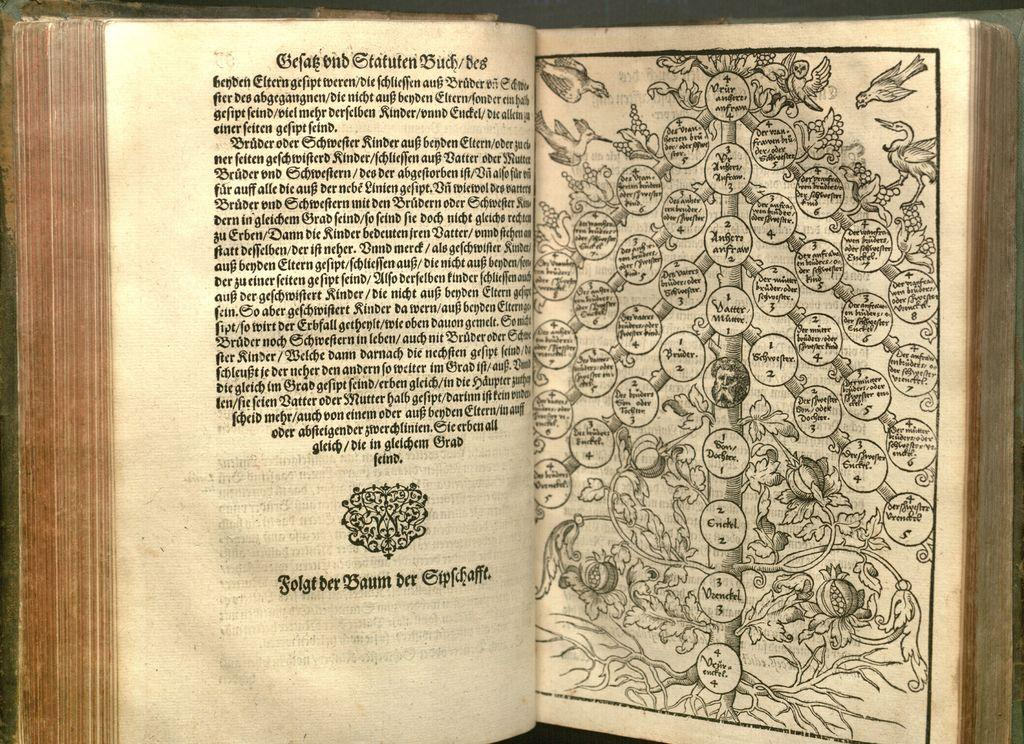<image>
Create a compact narrative representing the image presented. A book that is open to a page starting with the word Befab. 